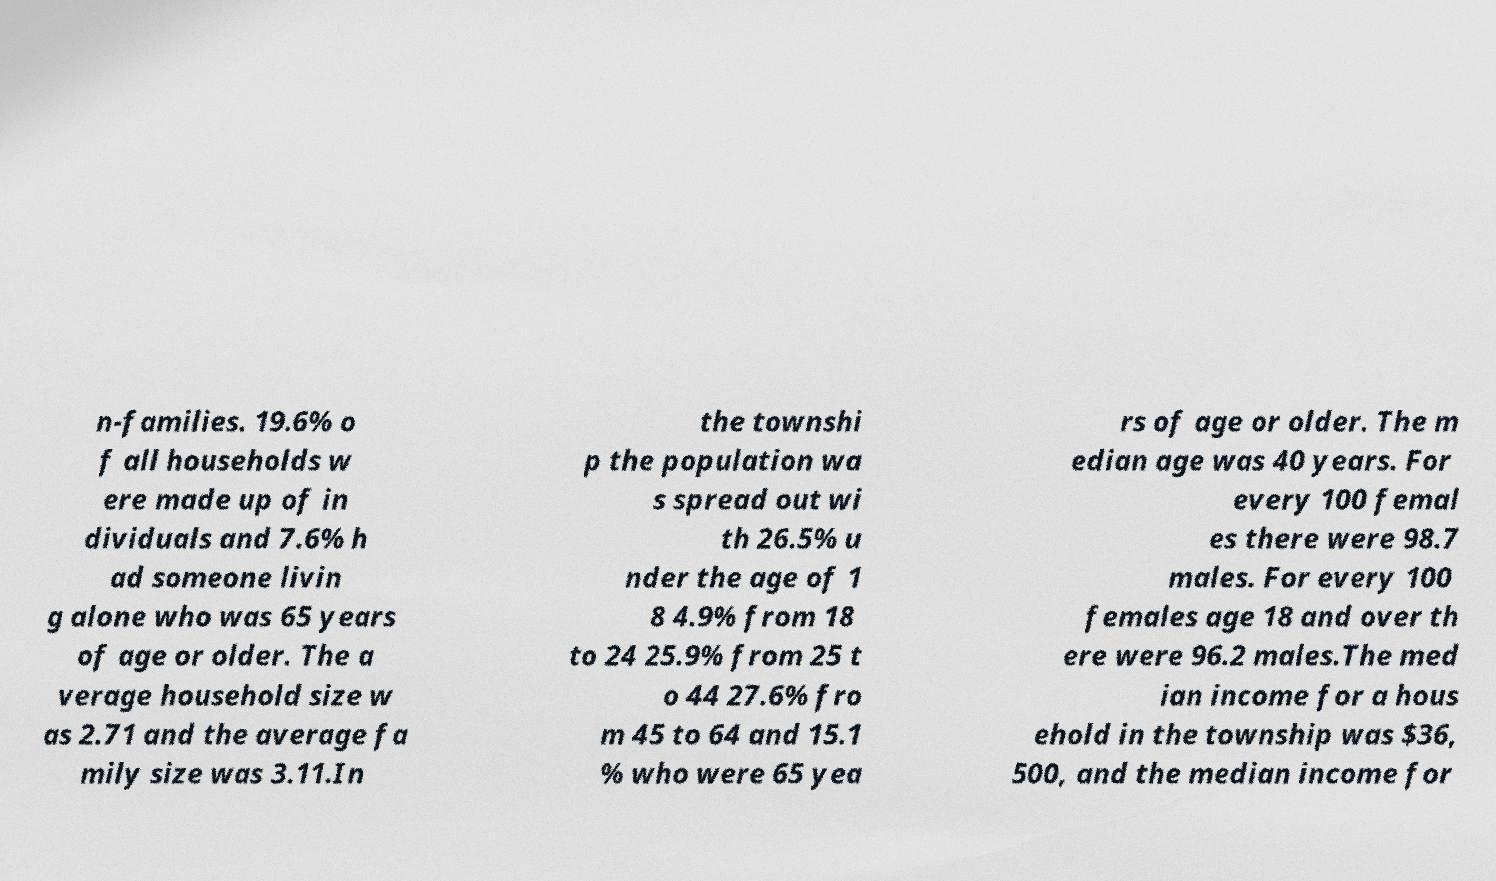For documentation purposes, I need the text within this image transcribed. Could you provide that? n-families. 19.6% o f all households w ere made up of in dividuals and 7.6% h ad someone livin g alone who was 65 years of age or older. The a verage household size w as 2.71 and the average fa mily size was 3.11.In the townshi p the population wa s spread out wi th 26.5% u nder the age of 1 8 4.9% from 18 to 24 25.9% from 25 t o 44 27.6% fro m 45 to 64 and 15.1 % who were 65 yea rs of age or older. The m edian age was 40 years. For every 100 femal es there were 98.7 males. For every 100 females age 18 and over th ere were 96.2 males.The med ian income for a hous ehold in the township was $36, 500, and the median income for 